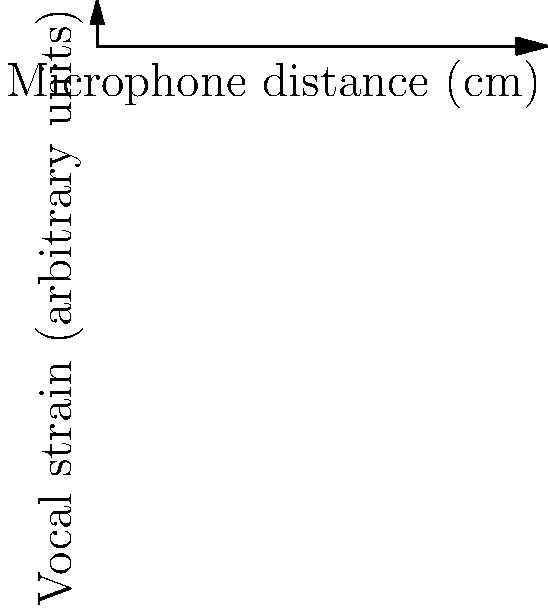Based on the graph showing the relationship between microphone distance and vocal strain, which microphone position would be most beneficial for reducing vocal strain during a long performance? Explain your reasoning considering the trade-offs between strain reduction and sound quality. To answer this question, let's analyze the graph step-by-step:

1. The x-axis represents the microphone distance from the singer's mouth in centimeters.
2. The y-axis represents vocal strain in arbitrary units.
3. The graph shows a decreasing trend in vocal strain as the microphone distance increases.

4. Point A (10 cm): Highest vocal strain (9 units)
5. Point B (30 cm): Reduced strain (7 units)
6. Point C (50 cm): Further reduced strain (5 units)
7. Point D (70 cm): Even lower strain (4 units)
8. Point E (90 cm): Lowest strain (3.5 units)

9. The curve flattens out between points D and E, suggesting diminishing returns in strain reduction beyond 70 cm.

10. Consider the trade-offs:
    - Closer microphones (A, B) provide better sound quality but cause higher vocal strain.
    - Farther microphones (D, E) significantly reduce strain but may compromise sound quality.

11. The optimal position should balance strain reduction and sound quality.

12. Point C (50 cm) offers a good compromise:
    - It provides substantial strain reduction compared to closer positions.
    - It's not so far as to severely impact sound quality.
    - It's before the point of diminishing returns in strain reduction.
Answer: Position C (50 cm) offers the best balance between strain reduction and sound quality for long performances. 